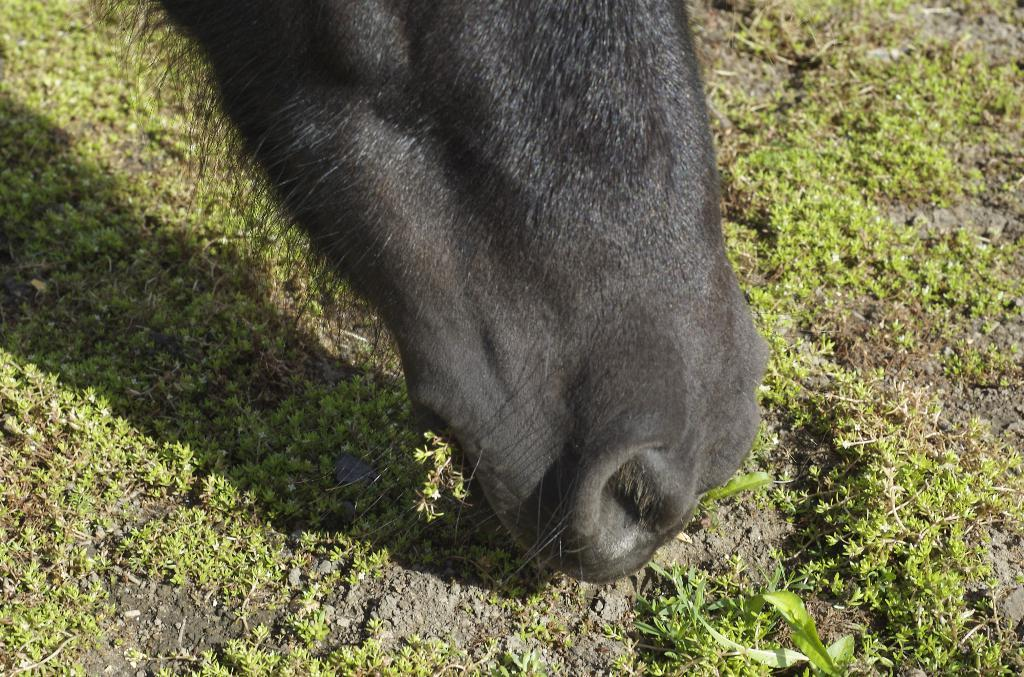What type of animal is present in the image? There is an animal in the image, and it is black in color. What is the color of the grass in the image? The grass in the image is green in color. What type of unit does the grandmother use to iron the linen in the image? There is no grandmother, unit, or linen present in the image. 